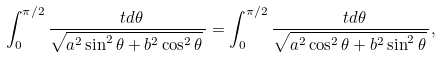<formula> <loc_0><loc_0><loc_500><loc_500>\int _ { 0 } ^ { \pi / 2 } \frac { \ t d \theta } { \sqrt { a ^ { 2 } \sin ^ { 2 } \theta + b ^ { 2 } \cos ^ { 2 } \theta } \, } = \int _ { 0 } ^ { \pi / 2 } \frac { \ t d \theta } { \sqrt { a ^ { 2 } \cos ^ { 2 } \theta + b ^ { 2 } \sin ^ { 2 } \theta } \, } ,</formula> 